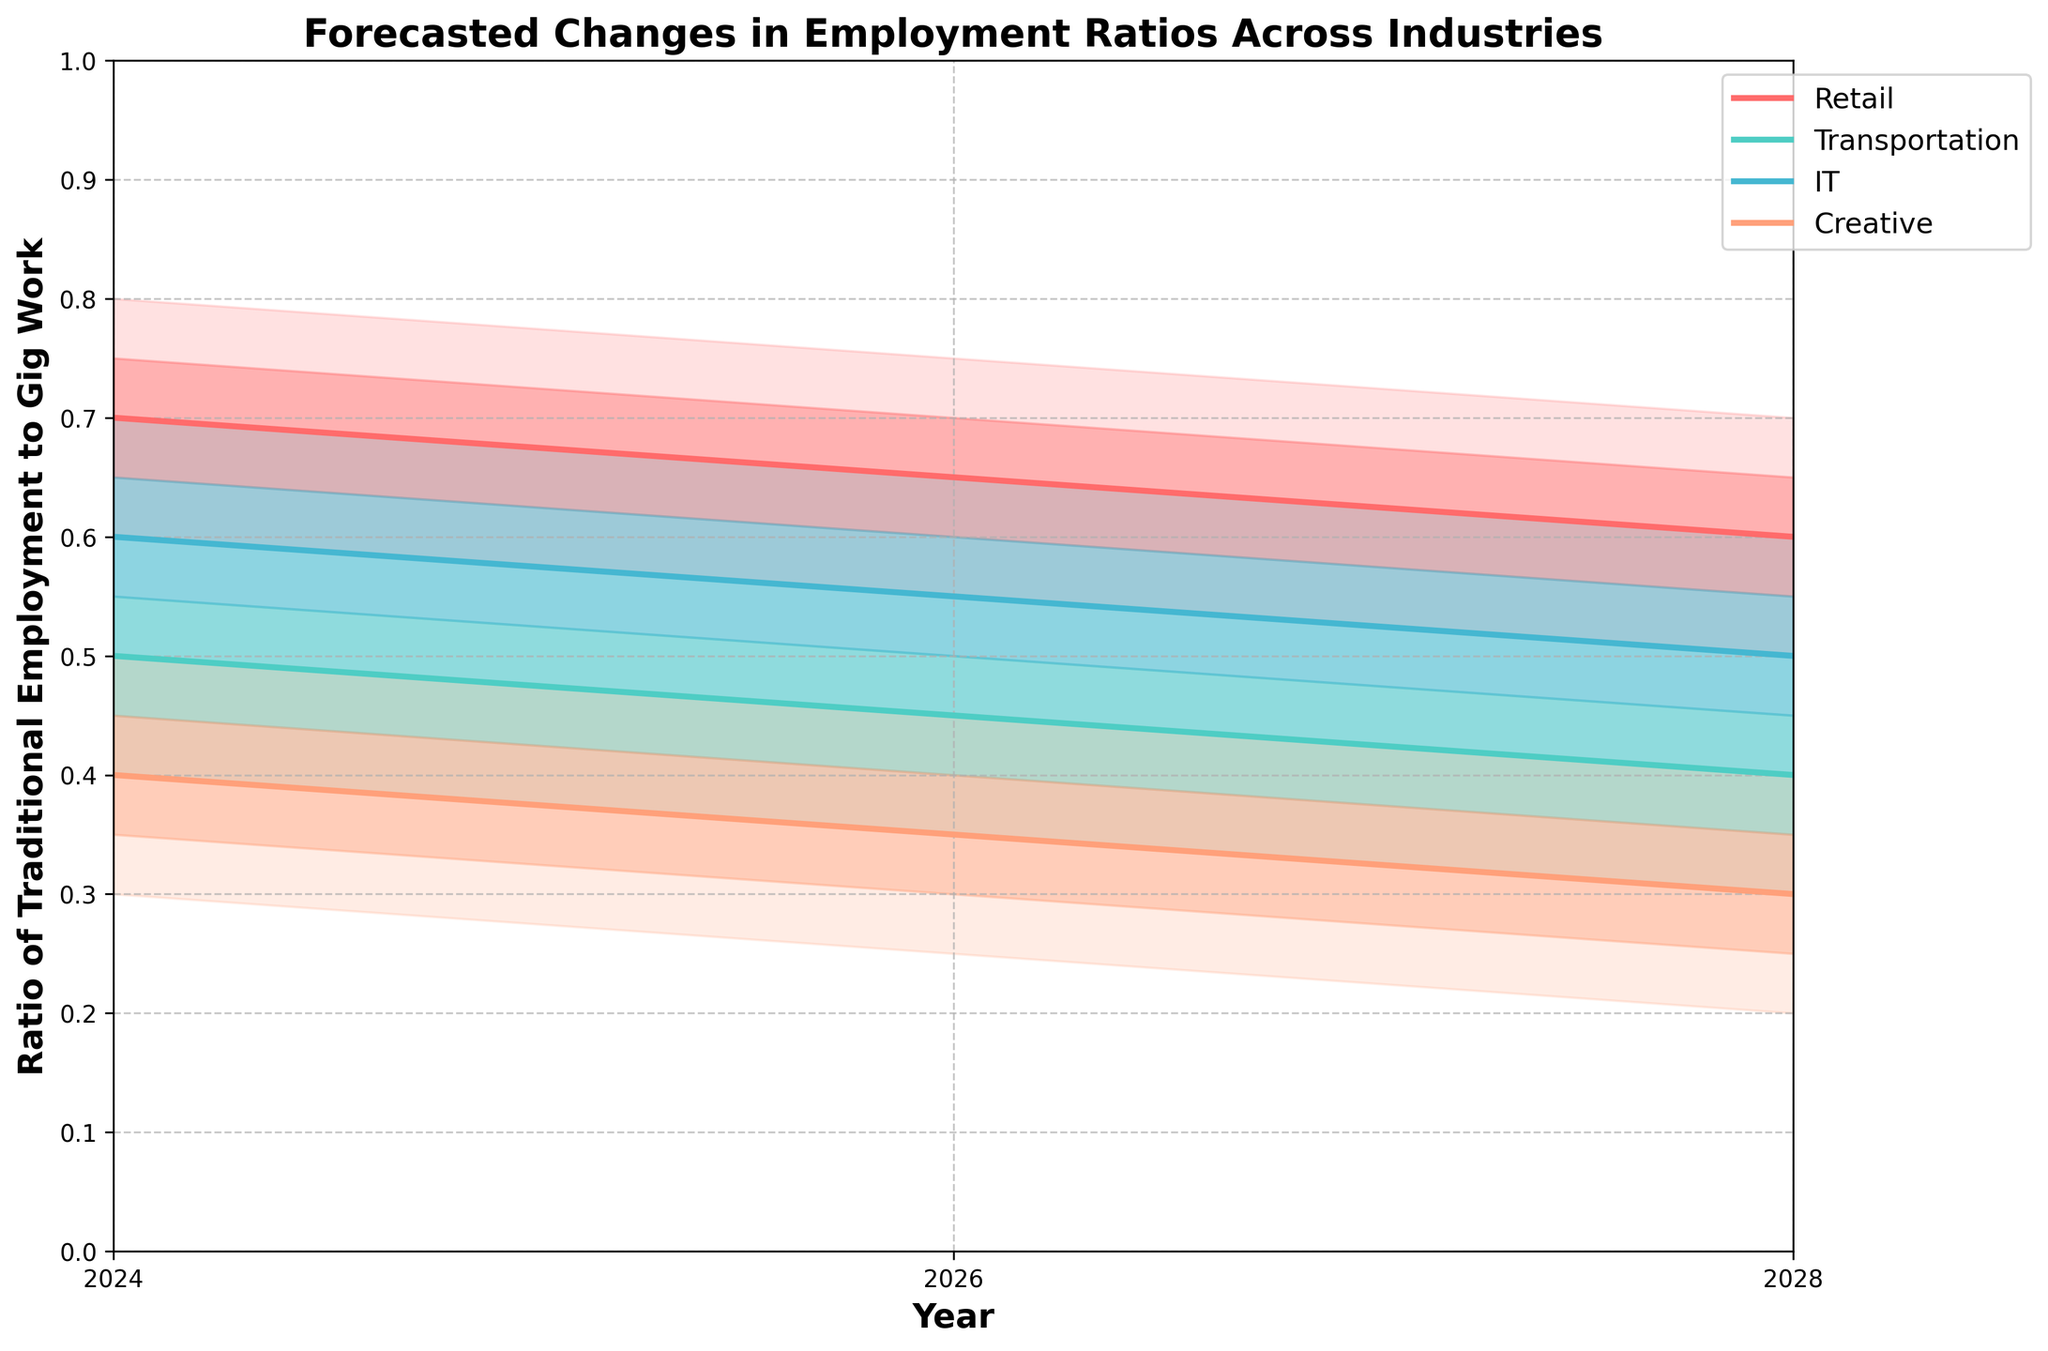What is the title of the chart? The title is usually located at the top of the chart. It specifies that the chart shows forecasted changes in employment ratios across industries.
Answer: Forecasted Changes in Employment Ratios Across Industries What is the median ratio for the IT industry in 2026? Locate the median value for the IT industry for the year 2026.
Answer: 0.55 Which industry is predicted to have the lowest median ratio in 2028? Compare the median values for all industries in 2028. The Creative industry has the lowest median value.
Answer: Creative Between 2024 and 2028, which industry shows the most consistent decrease in the median ratio? Track changes in the median ratio for each industry from 2024 to 2028. The Retail industry shows a steady decrease in its median values.
Answer: Retail What's the difference between the upper 90% and lower 10% limits for Transportation in 2024? Subtract the lower 10% limit from the upper 90% limit for Transportation in 2024. The upper limit is 0.6, and the lower limit is 0.4. So, the difference is 0.6 - 0.4 = 0.2.
Answer: 0.2 How does the uncertainty range (Upper90 - Lower10) for Retail in 2028 compare to IT in the same year? Calculate the range as Upper90 minus Lower10 for both industries in 2028 and then compare. Retail's range is 0.7 - 0.5 = 0.2, and IT's range is 0.6 - 0.4 = 0.2, making them equal.
Answer: Equal Are there any years where the Creative industry has a higher median ratio than the Transportation industry? Compare the median ratios for Creative and Transportation industries in each year listed. In all years, the Creative industry has a lower median ratio.
Answer: No For which industry does the interquartile range (Upper75 - Lower25) show the biggest reduction from 2024 to 2028? Calculate the interquartile range for each industry in 2024 and 2028, and identify the industry with the largest reduction. For Creative, in 2024: 0.45 - 0.35 = 0.1 and in 2028: 0.35 - 0.25 = 0.1. The Creative industry sees the biggest reduction.
Answer: Creative What trend can we observe in the traditional employment to gig work ratio for the IT industry from 2024 to 2028? Observe the trend in median values for the IT industry over the years 2024, 2026, and 2028. There is a consistent decrease from 0.6 to 0.55 and finally to 0.5.
Answer: Decreasing Which industry has the widest uncertainty range in 2024? Calculate the uncertainty range for each industry in 2024 and identify the widest range. Retail's range is the widest, calculated as 0.8 - 0.6 = 0.2.
Answer: Retail 